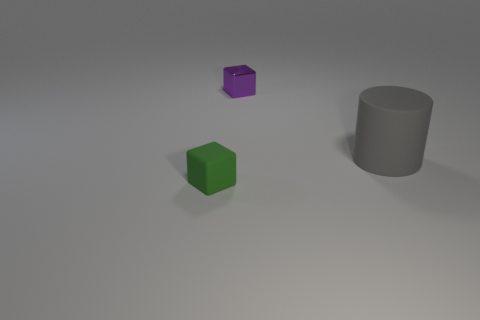Add 3 cyan rubber things. How many objects exist? 6 Subtract all cylinders. How many objects are left? 2 Subtract 0 yellow cylinders. How many objects are left? 3 Subtract all large cyan balls. Subtract all big rubber objects. How many objects are left? 2 Add 2 green rubber blocks. How many green rubber blocks are left? 3 Add 1 large gray matte cylinders. How many large gray matte cylinders exist? 2 